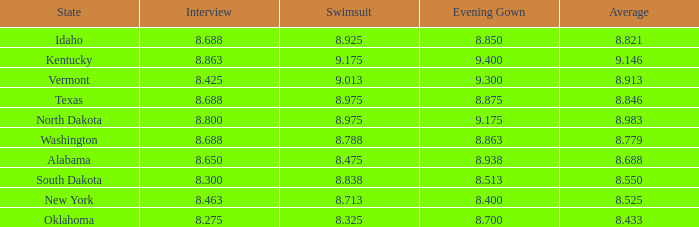175 and an interview score below None. 